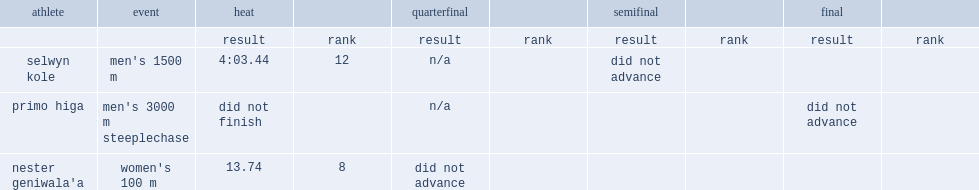What was the result that nester geniwala'a got in the heat? 13.74. 